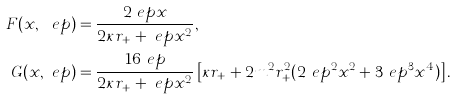<formula> <loc_0><loc_0><loc_500><loc_500>F ( x , \ e p ) & = \frac { 2 \ e p x } { 2 \kappa r _ { + } + \ e p x ^ { 2 } } , \\ G ( x , \ e p ) & = \frac { 1 6 \ e p } { 2 \kappa r _ { + } + \ e p x ^ { 2 } } \left [ \kappa r _ { + } + 2 m ^ { 2 } r _ { + } ^ { 2 } ( 2 \ e p ^ { 2 } x ^ { 2 } + 3 \ e p ^ { 3 } x ^ { 4 } ) \right ] .</formula> 